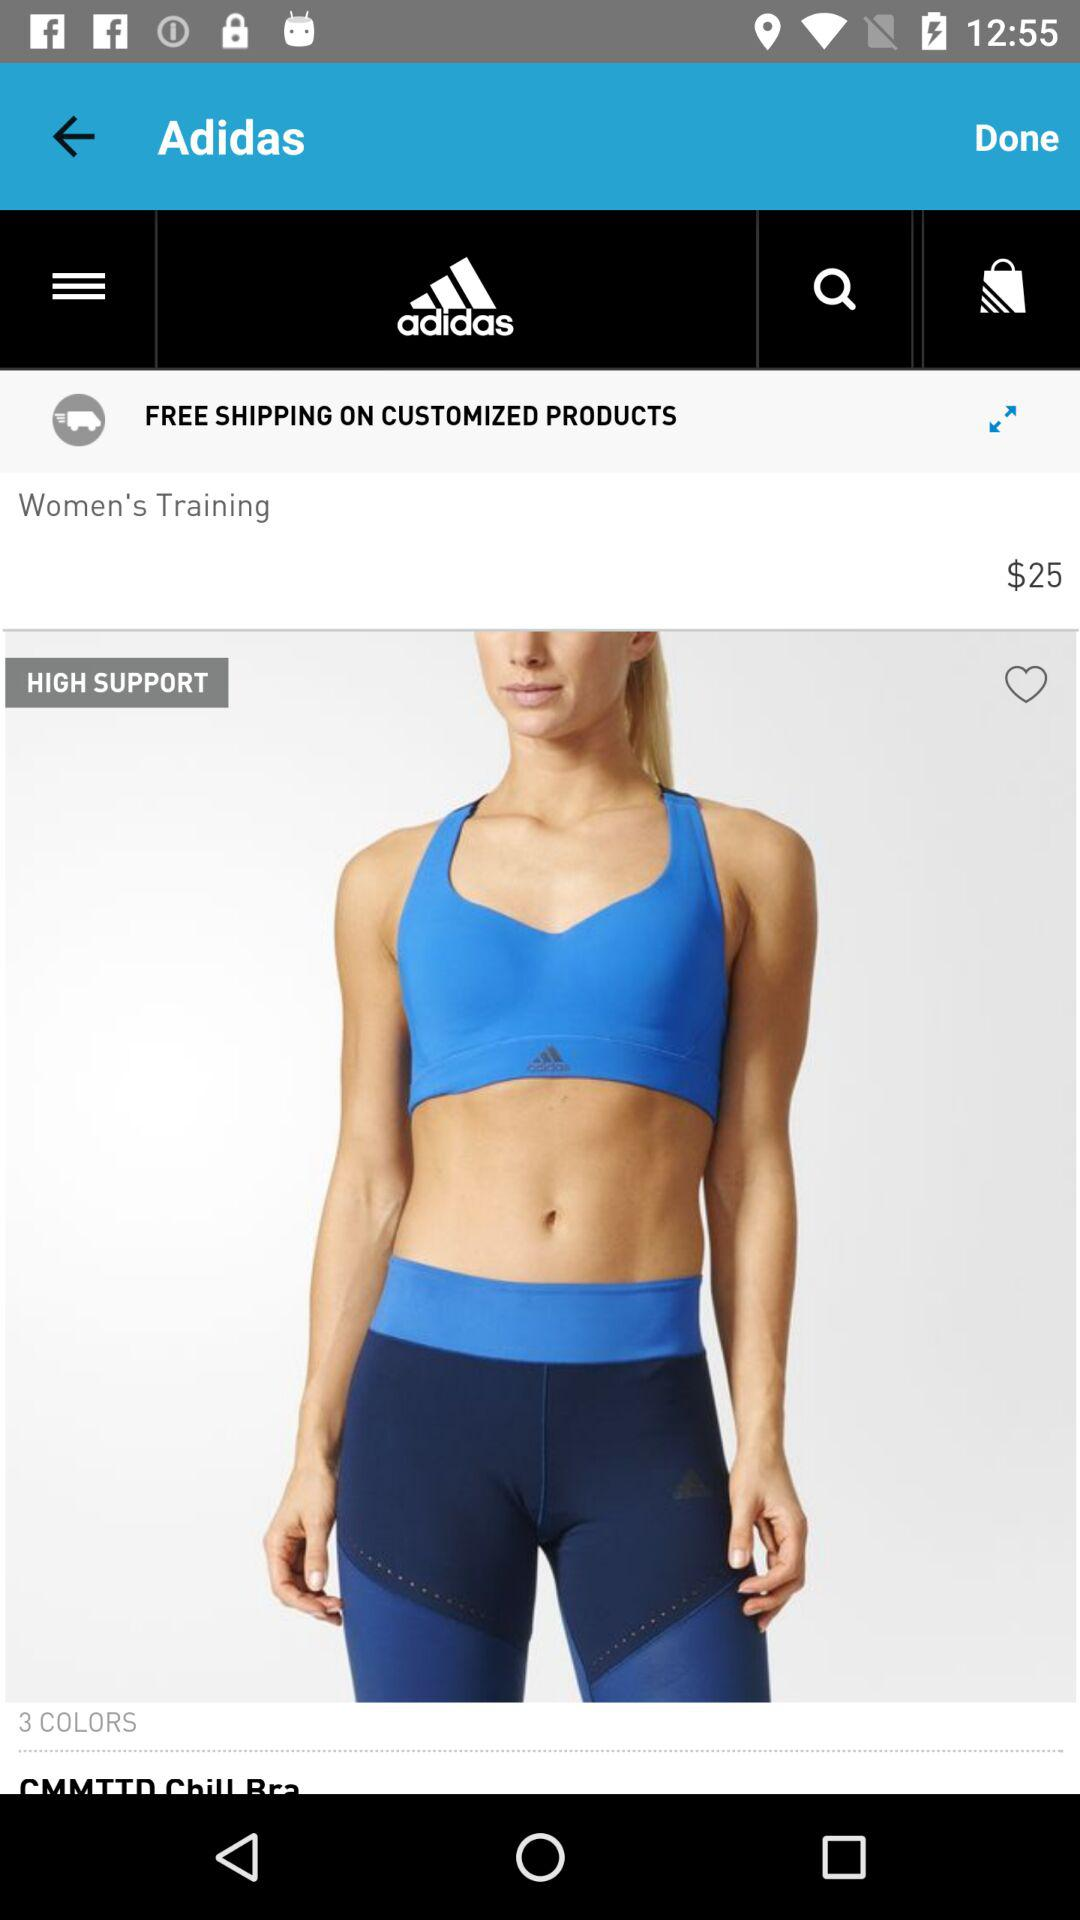What is the brand name? The brand name is Adidas. 